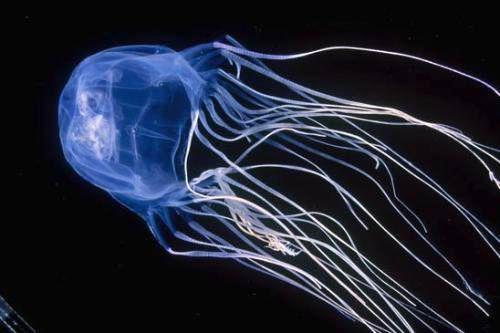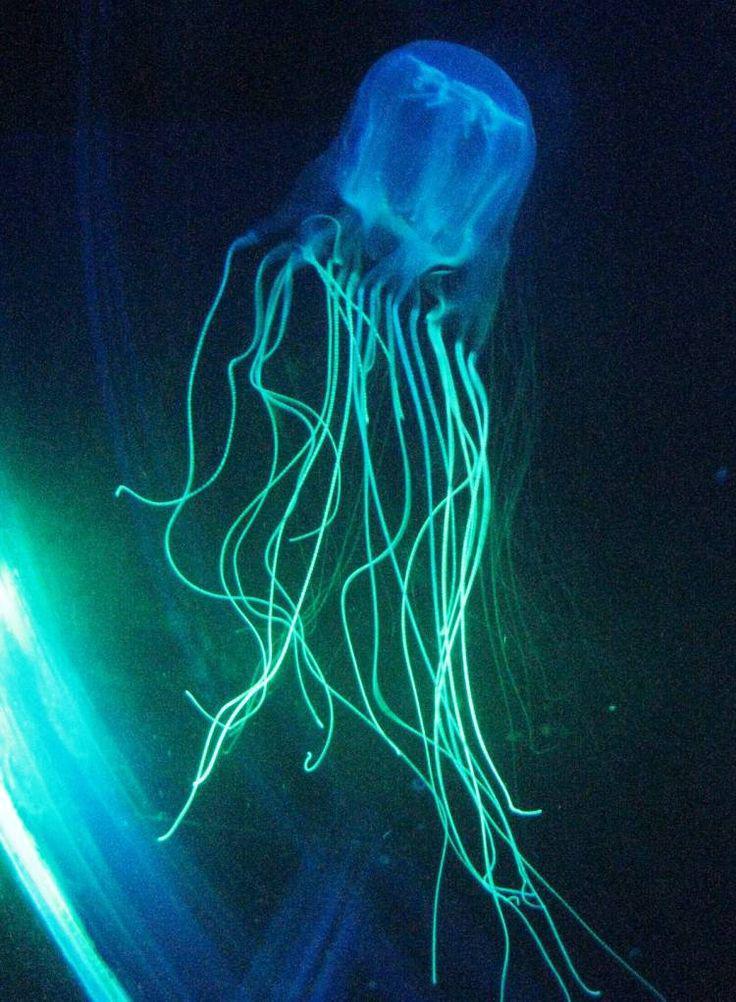The first image is the image on the left, the second image is the image on the right. Analyze the images presented: Is the assertion "Each image shows a jellyfish with a dome-shaped 'body' with only wisps of white visible inside it, and long, stringlike tentacles flowing from it." valid? Answer yes or no. Yes. The first image is the image on the left, the second image is the image on the right. Considering the images on both sides, is "The inside of the jellyfish's body is a different color." valid? Answer yes or no. No. 